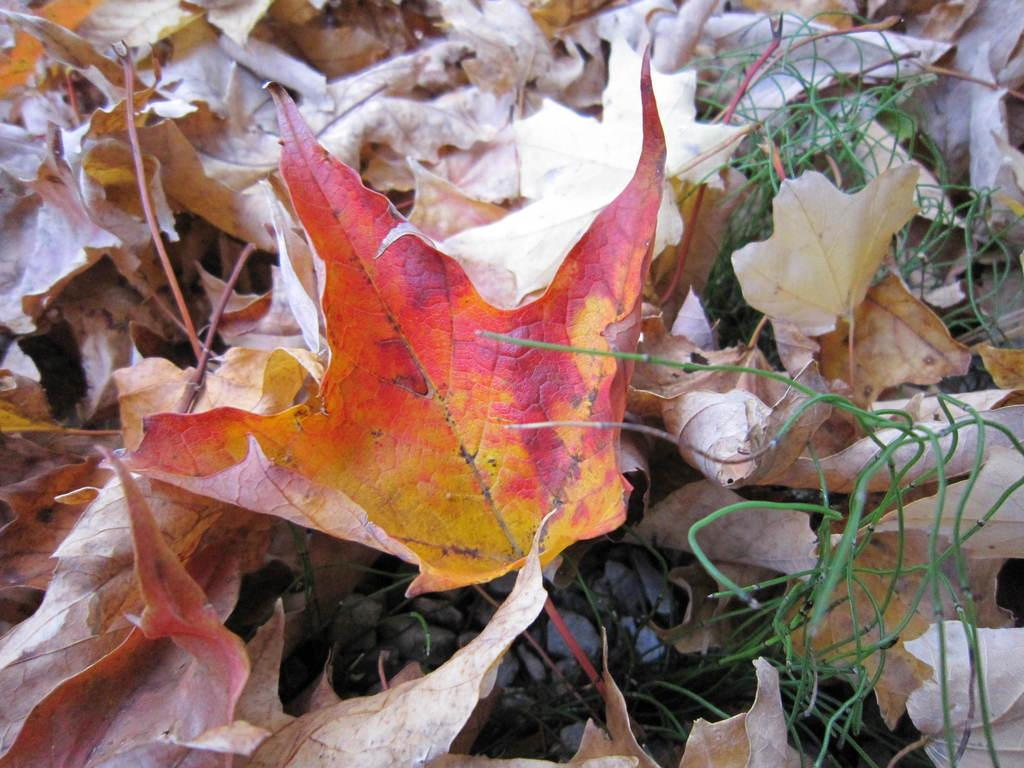What type of vegetation can be seen in the image? There are leaves and grass in the image. What else is present in the image besides vegetation? There are stones in the image. What type of eggs can be seen in the image? There are no eggs present in the image. What type of songs can be heard in the image? There is no audio in the image, so it is not possible to determine what songs might be heard. 